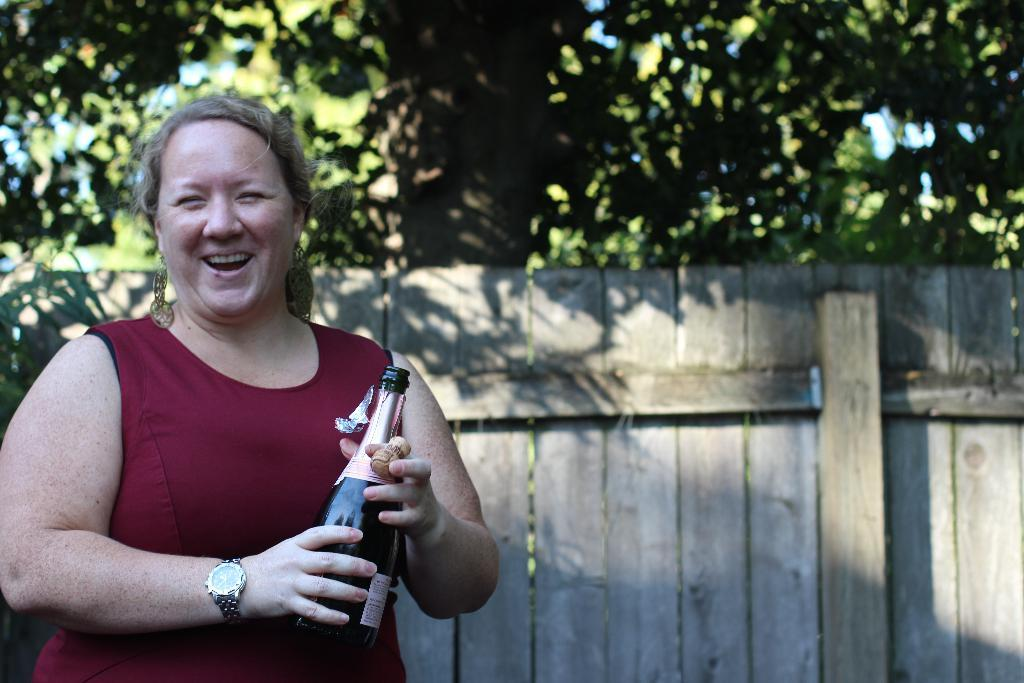Who is present in the image? There is a woman in the image. What is the woman holding in her hands? The woman is holding a bottle in her hands. What is the woman's facial expression? The woman is smiling. What can be seen in the background of the image? There are trees in the background of the image. How many eggs are being coached by the rabbits in the image? There are no eggs or rabbits present in the image. 